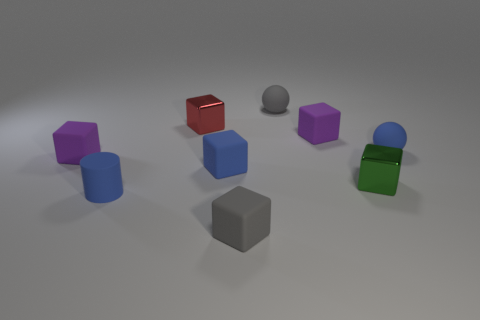How many blue things are matte objects or tiny rubber spheres?
Give a very brief answer. 3. How many rubber blocks are the same color as the tiny rubber cylinder?
Give a very brief answer. 1. Are the gray sphere and the blue cube made of the same material?
Keep it short and to the point. Yes. There is a small purple thing that is to the left of the tiny red thing; what number of tiny purple objects are on the right side of it?
Make the answer very short. 1. How many small cylinders have the same material as the blue sphere?
Your answer should be very brief. 1. There is a green metallic thing that is in front of the tiny red metal object; is it the same shape as the red thing?
Ensure brevity in your answer.  Yes. What is the shape of the shiny object that is behind the small purple matte cube to the right of the rubber cylinder?
Your answer should be compact. Cube. The other tiny metal thing that is the same shape as the red shiny object is what color?
Keep it short and to the point. Green. Does the cylinder have the same color as the sphere that is in front of the red shiny thing?
Your answer should be very brief. Yes. There is a tiny matte thing that is behind the blue matte sphere and in front of the tiny gray ball; what is its shape?
Provide a short and direct response. Cube. 